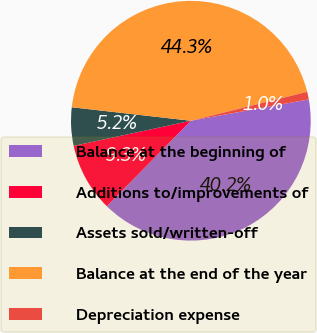Convert chart to OTSL. <chart><loc_0><loc_0><loc_500><loc_500><pie_chart><fcel>Balance at the beginning of<fcel>Additions to/improvements of<fcel>Assets sold/written-off<fcel>Balance at the end of the year<fcel>Depreciation expense<nl><fcel>40.21%<fcel>9.27%<fcel>5.16%<fcel>44.32%<fcel>1.04%<nl></chart> 